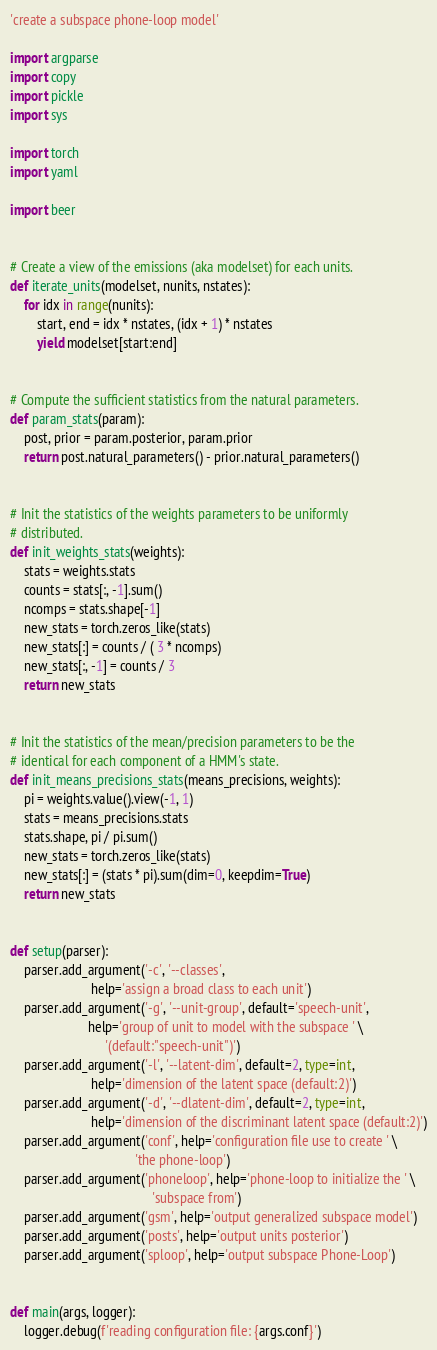<code> <loc_0><loc_0><loc_500><loc_500><_Python_>
'create a subspace phone-loop model'

import argparse
import copy
import pickle
import sys

import torch
import yaml

import beer


# Create a view of the emissions (aka modelset) for each units.
def iterate_units(modelset, nunits, nstates):
    for idx in range(nunits):
        start, end = idx * nstates, (idx + 1) * nstates
        yield modelset[start:end]


# Compute the sufficient statistics from the natural parameters.
def param_stats(param):
    post, prior = param.posterior, param.prior
    return post.natural_parameters() - prior.natural_parameters()


# Init the statistics of the weights parameters to be uniformly
# distributed.
def init_weights_stats(weights):
    stats = weights.stats
    counts = stats[:, -1].sum()
    ncomps = stats.shape[-1]
    new_stats = torch.zeros_like(stats)
    new_stats[:] = counts / ( 3 * ncomps)
    new_stats[:, -1] = counts / 3
    return new_stats


# Init the statistics of the mean/precision parameters to be the
# identical for each component of a HMM's state.
def init_means_precisions_stats(means_precisions, weights):
    pi = weights.value().view(-1, 1)
    stats = means_precisions.stats
    stats.shape, pi / pi.sum()
    new_stats = torch.zeros_like(stats)
    new_stats[:] = (stats * pi).sum(dim=0, keepdim=True)
    return new_stats


def setup(parser):
    parser.add_argument('-c', '--classes',
                        help='assign a broad class to each unit')
    parser.add_argument('-g', '--unit-group', default='speech-unit',
                       help='group of unit to model with the subspace ' \
                            '(default:"speech-unit")')
    parser.add_argument('-l', '--latent-dim', default=2, type=int,
                        help='dimension of the latent space (default:2)')
    parser.add_argument('-d', '--dlatent-dim', default=2, type=int,
                        help='dimension of the discriminant latent space (default:2)')
    parser.add_argument('conf', help='configuration file use to create ' \
                                     'the phone-loop')
    parser.add_argument('phoneloop', help='phone-loop to initialize the ' \
                                          'subspace from')
    parser.add_argument('gsm', help='output generalized subspace model')
    parser.add_argument('posts', help='output units posterior')
    parser.add_argument('sploop', help='output subspace Phone-Loop')


def main(args, logger):
    logger.debug(f'reading configuration file: {args.conf}')</code> 